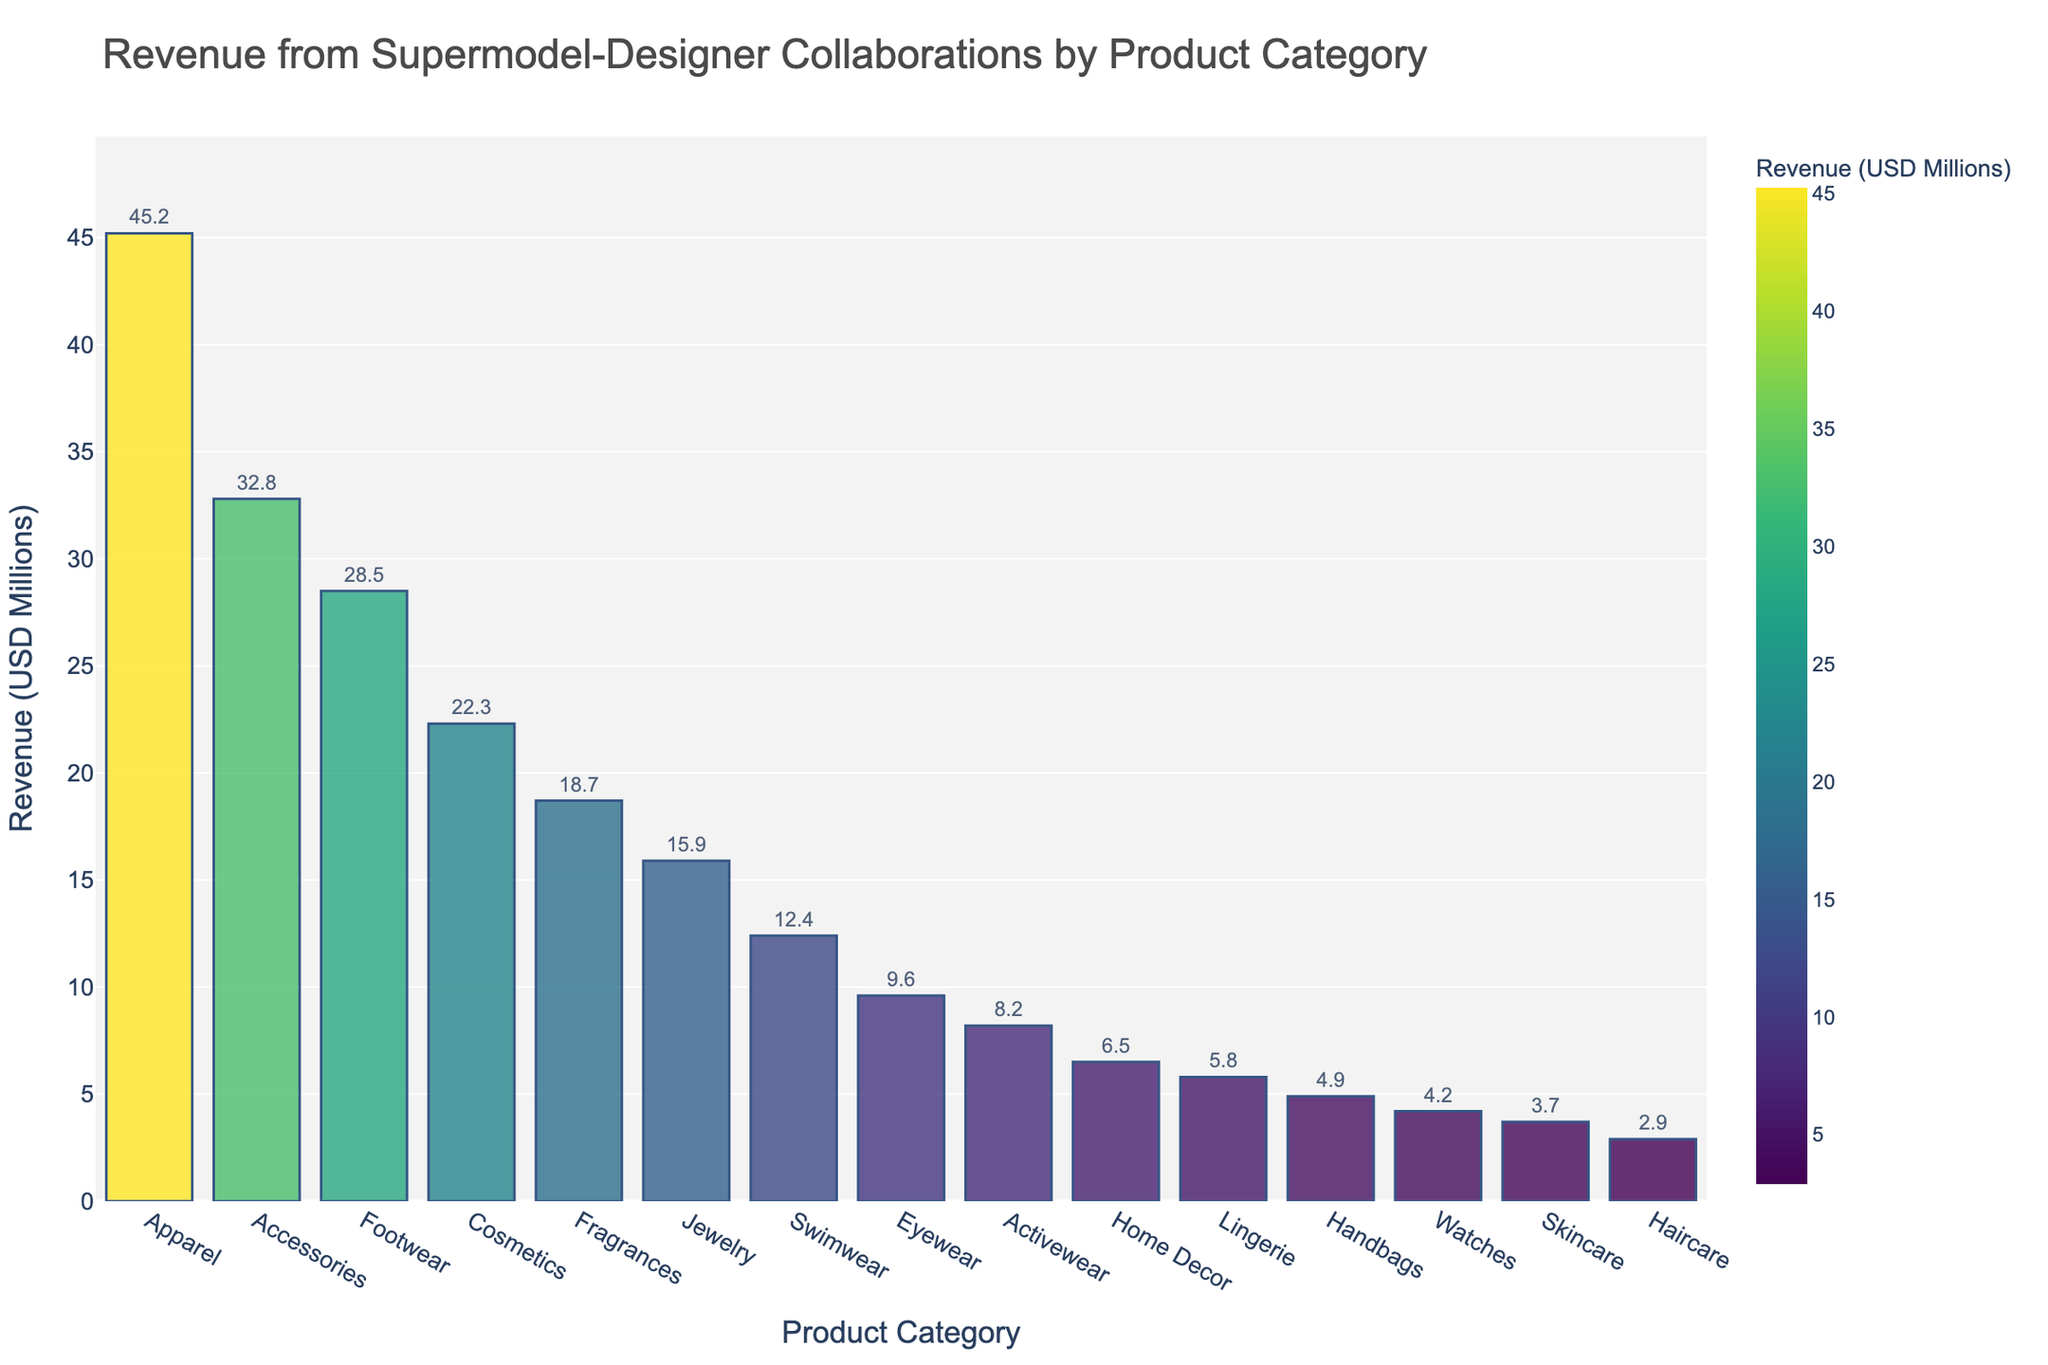Which product category generated the highest revenue? The bar chart visually shows the revenue for each product category, and the tallest bar represents the highest revenue. The Apparel category has the highest revenue.
Answer: Apparel Which product category generated the lowest revenue? Looking at the bar chart, the shortest bar represents the lowest revenue. The Haircare category has the lowest revenue.
Answer: Haircare How much more revenue did Apparel generate than Haircare? The Apparel category generated 45.2 million, and Haircare generated 2.9 million. The difference is 45.2 - 2.9.
Answer: 42.3 million What is the combined revenue of Accessories and Footwear? The Accessories category generated 32.8 million, and Footwear generated 28.5 million. Adding these two gives 32.8 + 28.5.
Answer: 61.3 million Which category generated more revenue, Swimwear or Eyewear? By comparing the heights of the bars, Swimwear at 12.4 million is higher than Eyewear at 9.6 million.
Answer: Swimwear Is the revenue from Fragrances higher than that from Jewelry? Comparing the heights of the bars shows Fragrances at 18.7 million and Jewelry at 15.9 million. Fragrances is higher.
Answer: Yes What is the average revenue of the top three categories? The top three categories are Apparel (45.2), Accessories (32.8), and Footwear (28.5). Summing these up gives 106.5, and dividing by 3 gives 106.5/3.
Answer: 35.5 million Is the revenue generated by Home Decor more or less than half of that generated by Apparel? Half of the revenue for Apparel is 45.2/2 = 22.6. Home Decor generated 6.5 million, which is less than 22.6.
Answer: Less What is the total revenue generated by the categories with more than 20 million revenue? The categories with revenues greater than 20 million are Apparel (45.2), Accessories (32.8), Footwear (28.5), and Cosmetics (22.3). Adding these together gives 45.2 + 32.8 + 28.5 + 22.3.
Answer: 128.8 million Which category has closer revenue to Lingerie, Watches or Skincare? Lingerie is at 5.8 million; Watches are at 4.2 million, and Skincare is at 3.7 million. Watches are closer to 5.8 than Skincare.
Answer: Watches 